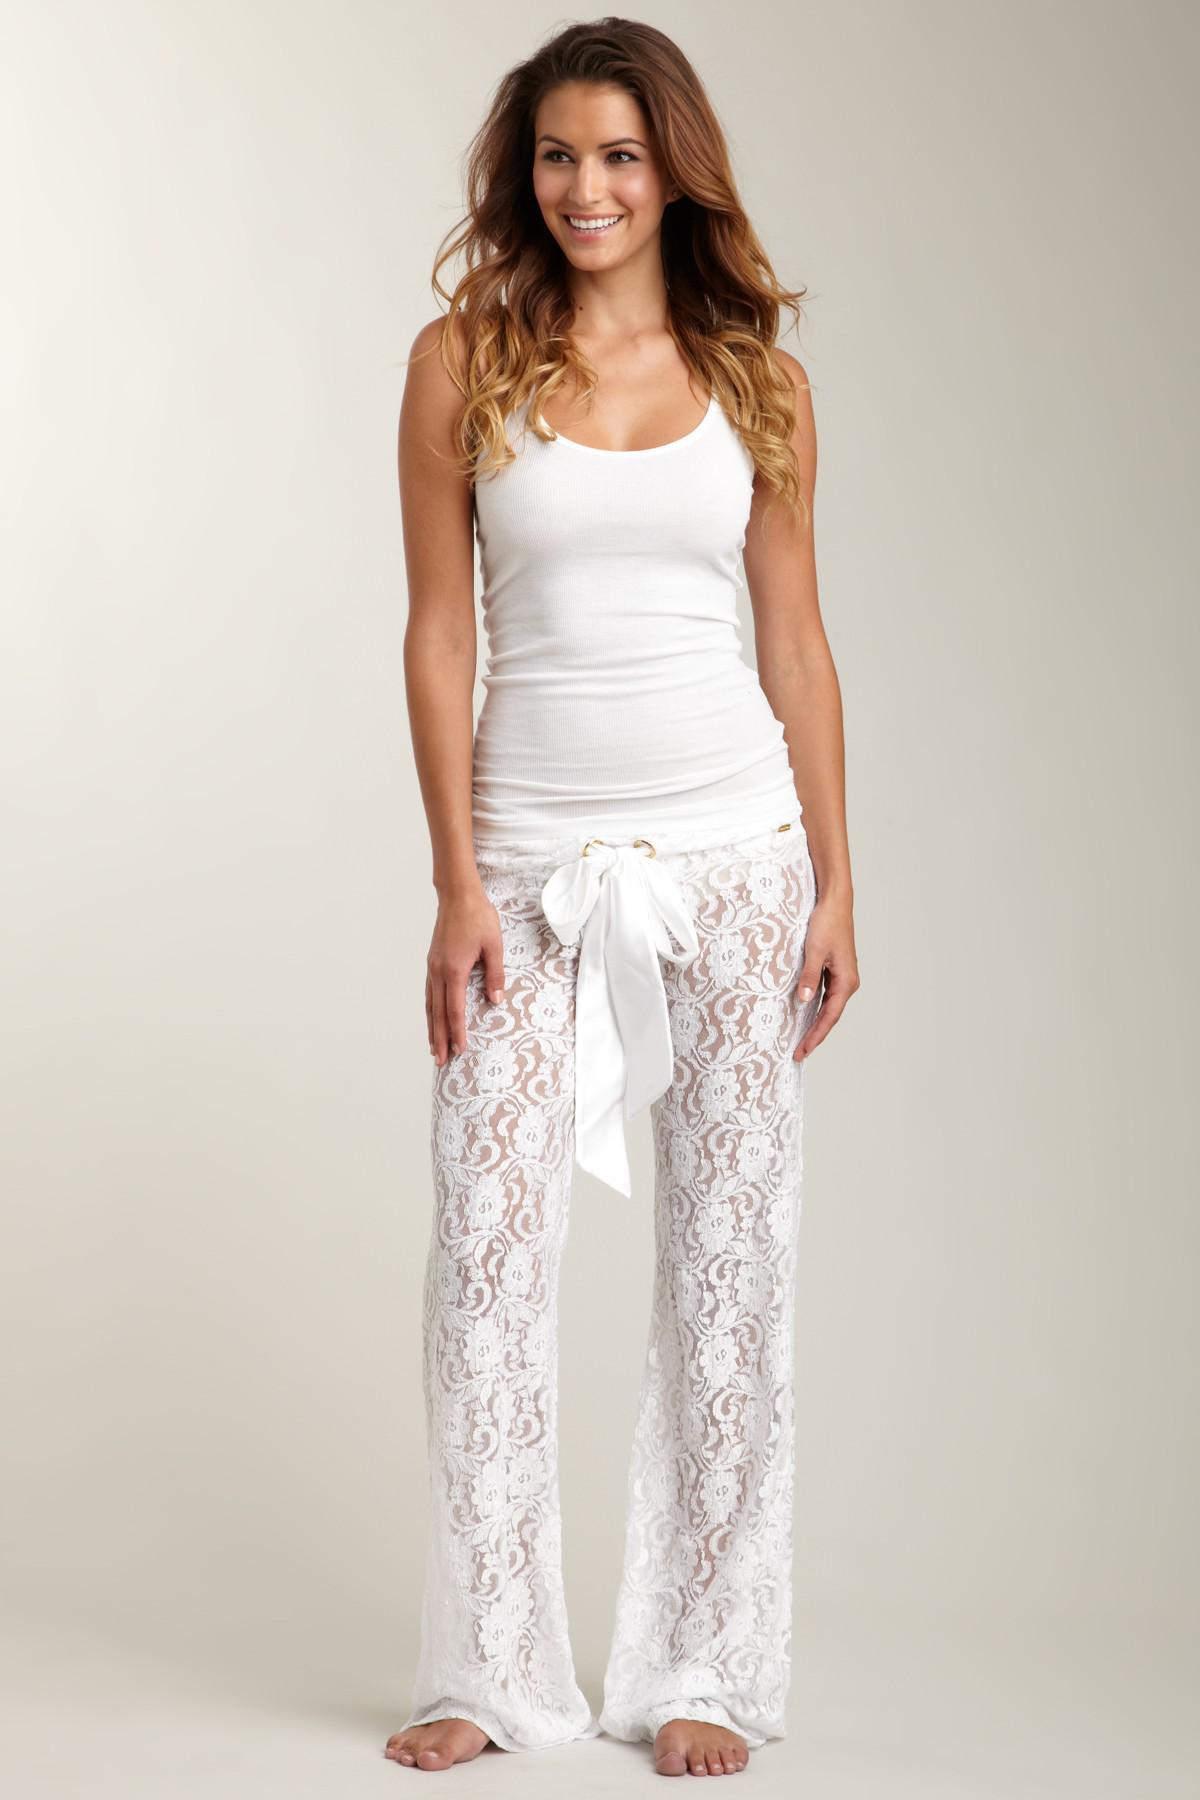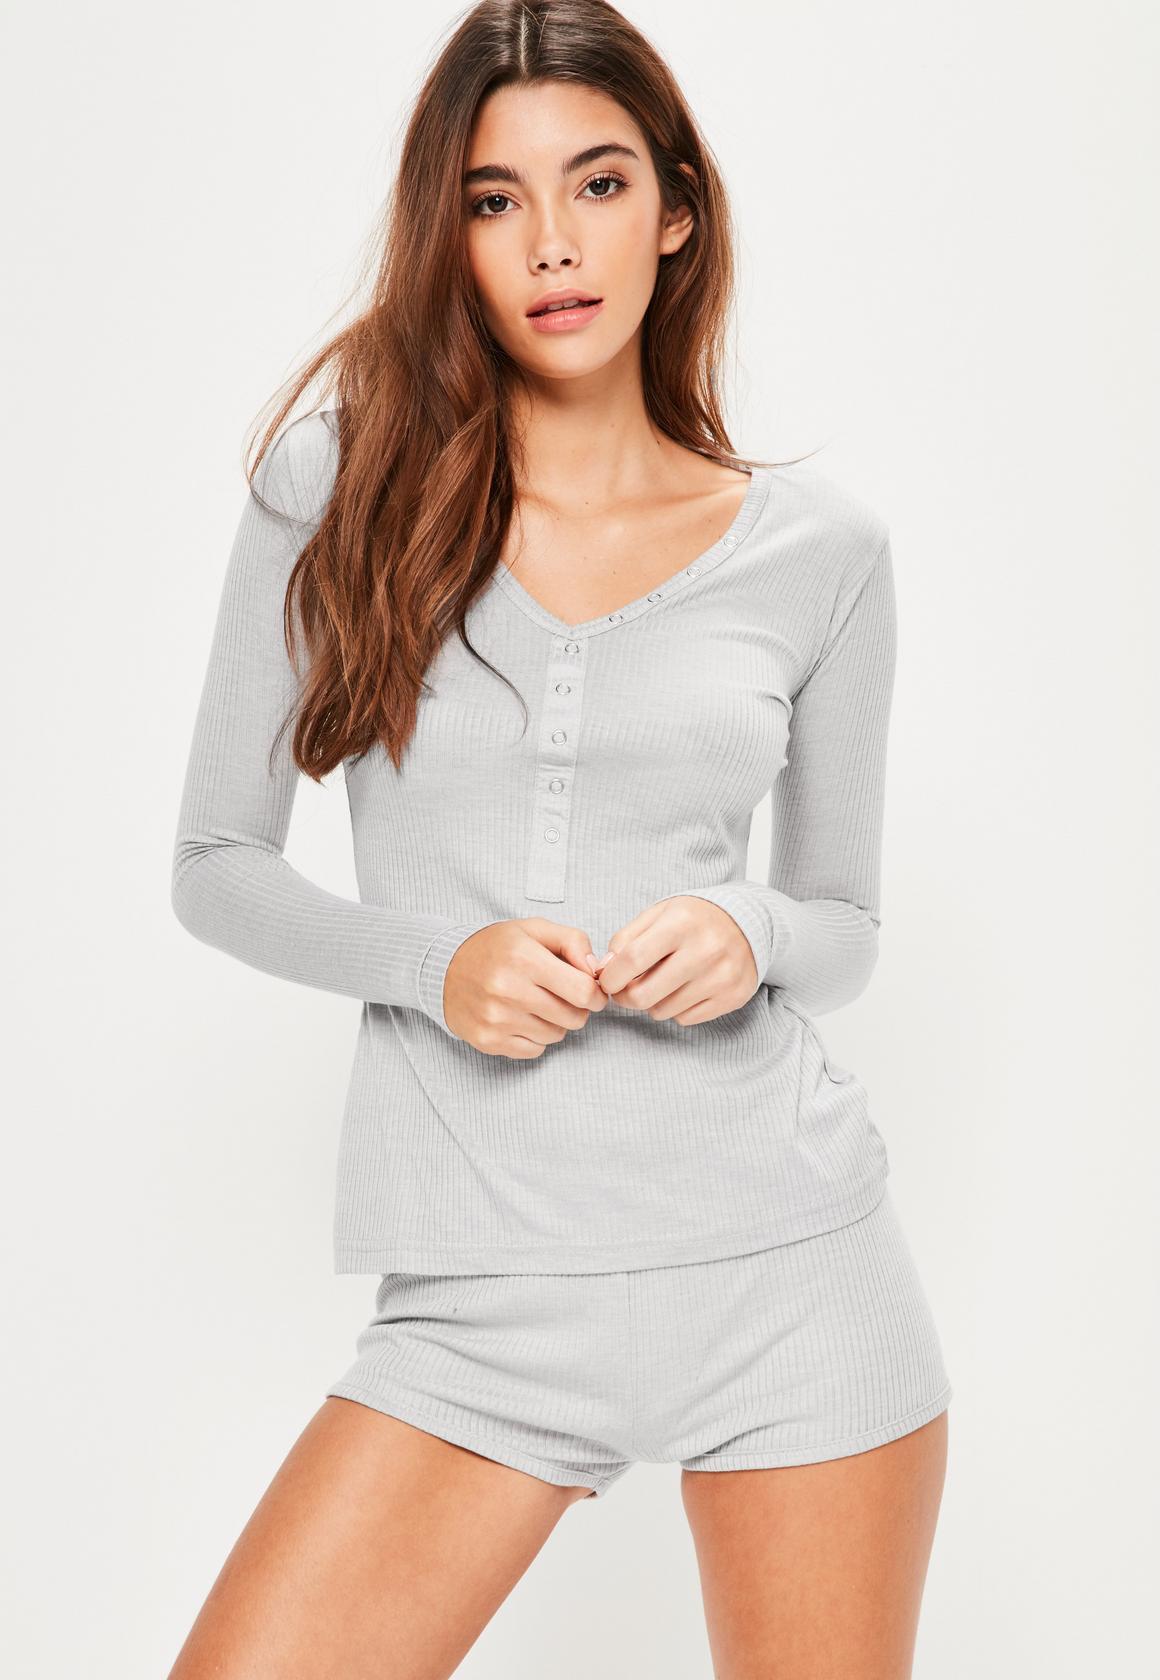The first image is the image on the left, the second image is the image on the right. Assess this claim about the two images: "In the images, both models wear bottoms that are virtually the same length.". Correct or not? Answer yes or no. No. 